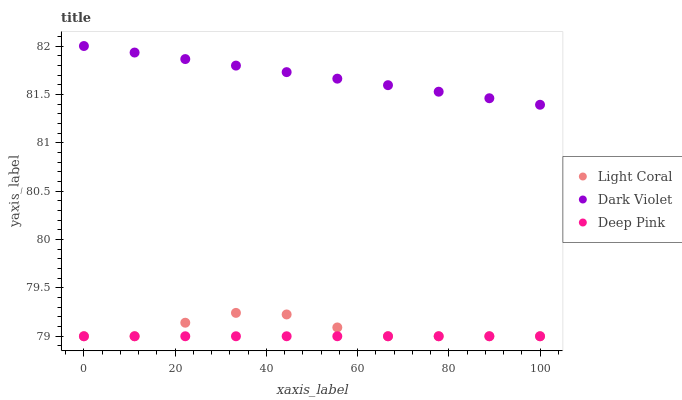Does Deep Pink have the minimum area under the curve?
Answer yes or no. Yes. Does Dark Violet have the maximum area under the curve?
Answer yes or no. Yes. Does Dark Violet have the minimum area under the curve?
Answer yes or no. No. Does Deep Pink have the maximum area under the curve?
Answer yes or no. No. Is Deep Pink the smoothest?
Answer yes or no. Yes. Is Light Coral the roughest?
Answer yes or no. Yes. Is Dark Violet the smoothest?
Answer yes or no. No. Is Dark Violet the roughest?
Answer yes or no. No. Does Light Coral have the lowest value?
Answer yes or no. Yes. Does Dark Violet have the lowest value?
Answer yes or no. No. Does Dark Violet have the highest value?
Answer yes or no. Yes. Does Deep Pink have the highest value?
Answer yes or no. No. Is Light Coral less than Dark Violet?
Answer yes or no. Yes. Is Dark Violet greater than Deep Pink?
Answer yes or no. Yes. Does Light Coral intersect Deep Pink?
Answer yes or no. Yes. Is Light Coral less than Deep Pink?
Answer yes or no. No. Is Light Coral greater than Deep Pink?
Answer yes or no. No. Does Light Coral intersect Dark Violet?
Answer yes or no. No. 